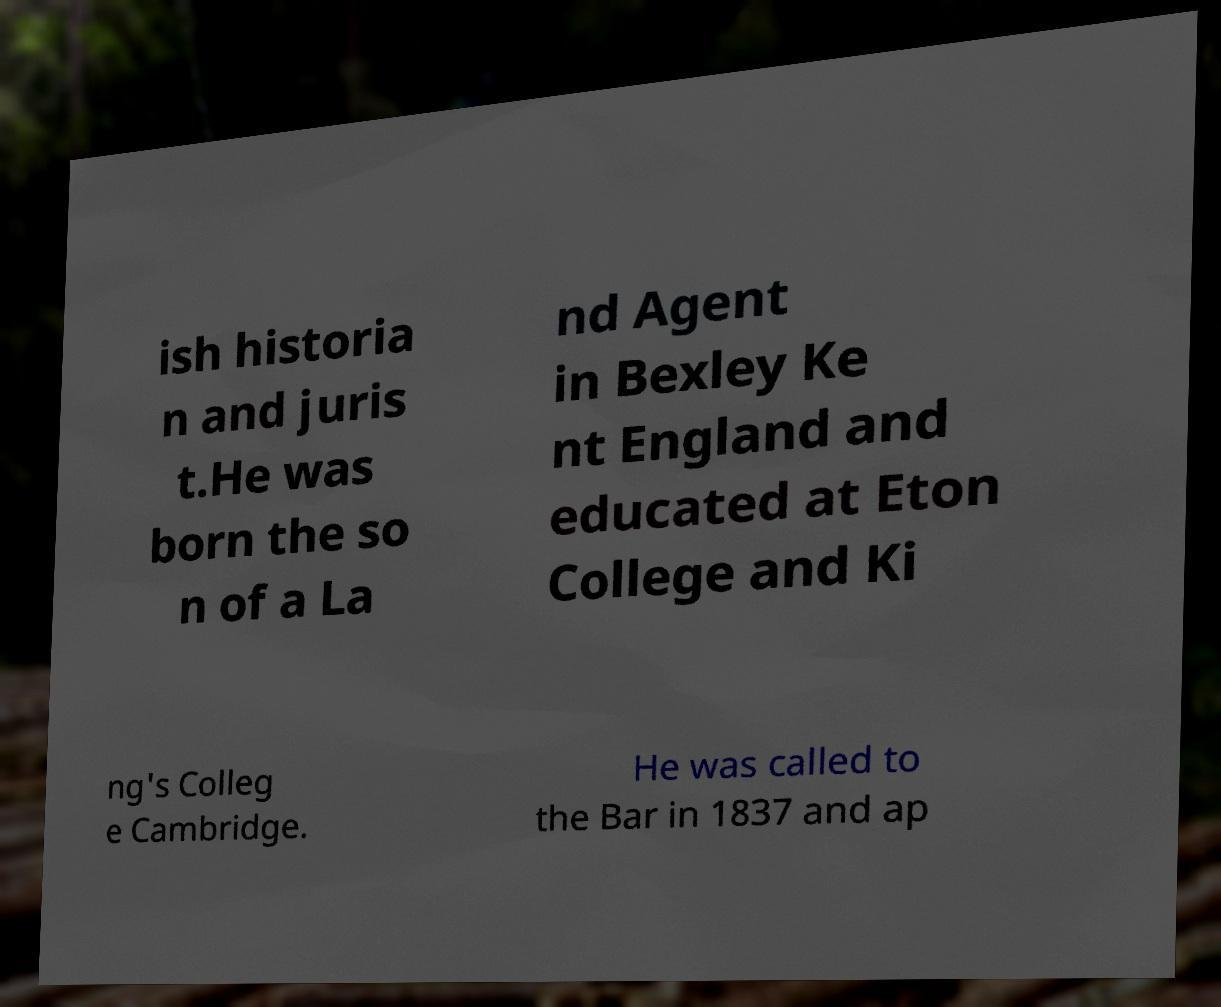I need the written content from this picture converted into text. Can you do that? ish historia n and juris t.He was born the so n of a La nd Agent in Bexley Ke nt England and educated at Eton College and Ki ng's Colleg e Cambridge. He was called to the Bar in 1837 and ap 